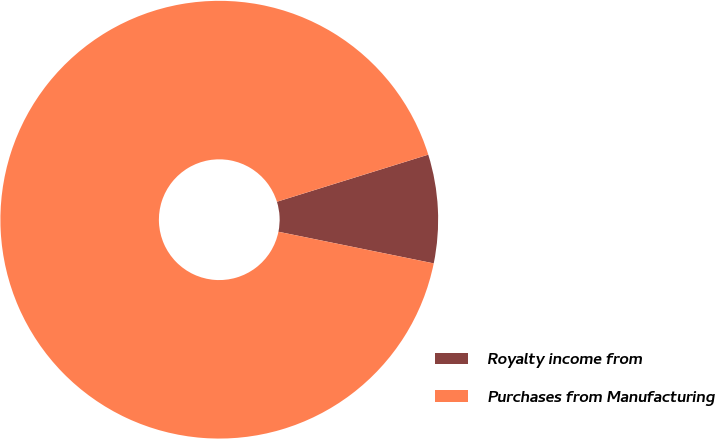Convert chart to OTSL. <chart><loc_0><loc_0><loc_500><loc_500><pie_chart><fcel>Royalty income from<fcel>Purchases from Manufacturing<nl><fcel>8.0%<fcel>92.0%<nl></chart> 